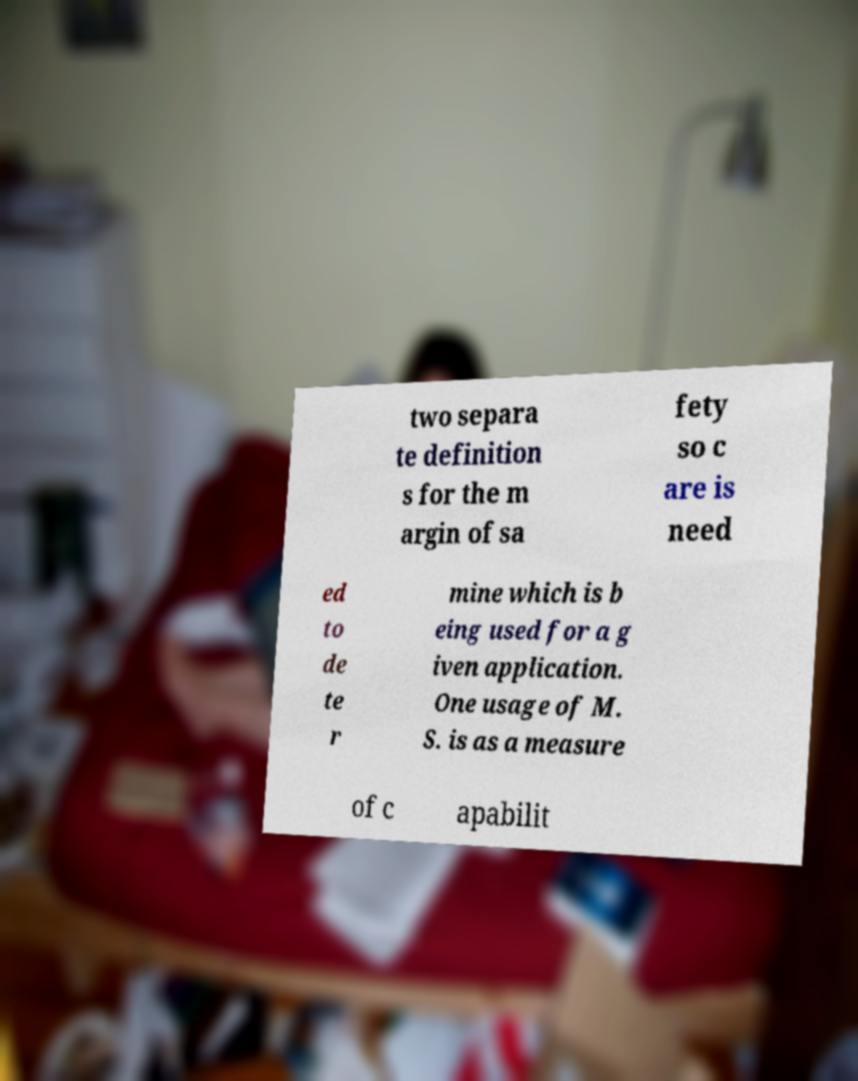Could you assist in decoding the text presented in this image and type it out clearly? two separa te definition s for the m argin of sa fety so c are is need ed to de te r mine which is b eing used for a g iven application. One usage of M. S. is as a measure of c apabilit 